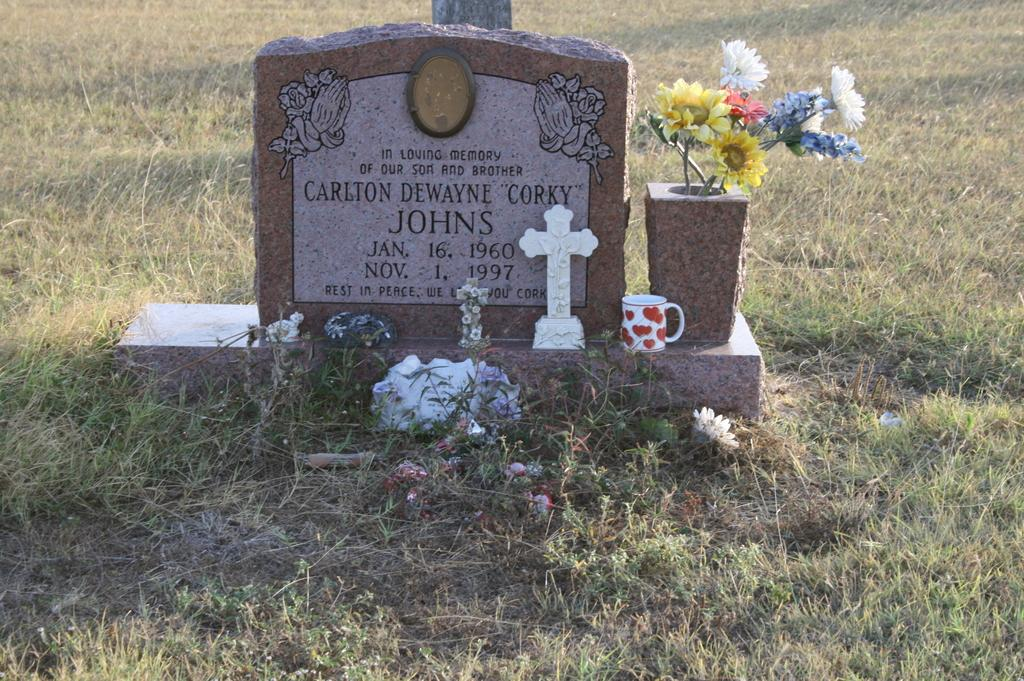What is the main subject of the image? There is a memorial stone in the image. What symbol can be seen in the image? There is a cross symbol in the image. What type of decoration is present in the image? There are flowers in the image. What type of container is visible in the image? There is a stone vase in the image. What type of natural environment is visible in the image? There is grass visible in the image. What type of property is being sold in the image? There is no indication of a property being sold in the image. What type of learning material is visible in the image? There is no learning material visible in the image. What type of peace symbol is visible in the image? There is no peace symbol visible in the image. 